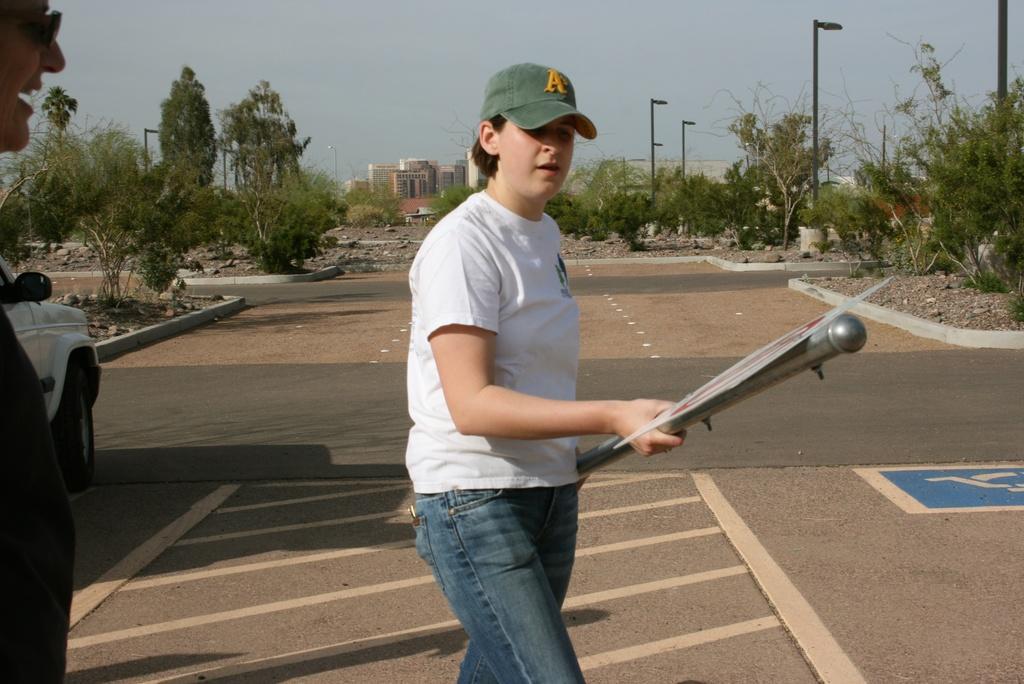Describe this image in one or two sentences. In this picture we can see a person holding a signboard to the pole in his hand. There is a vehicle on left side. We can see few trees, street lights and a building in the background. We can see another person on left side. 